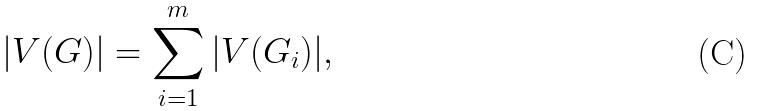Convert formula to latex. <formula><loc_0><loc_0><loc_500><loc_500>| V ( G ) | = \sum _ { i = 1 } ^ { m } | V ( G _ { i } ) | ,</formula> 